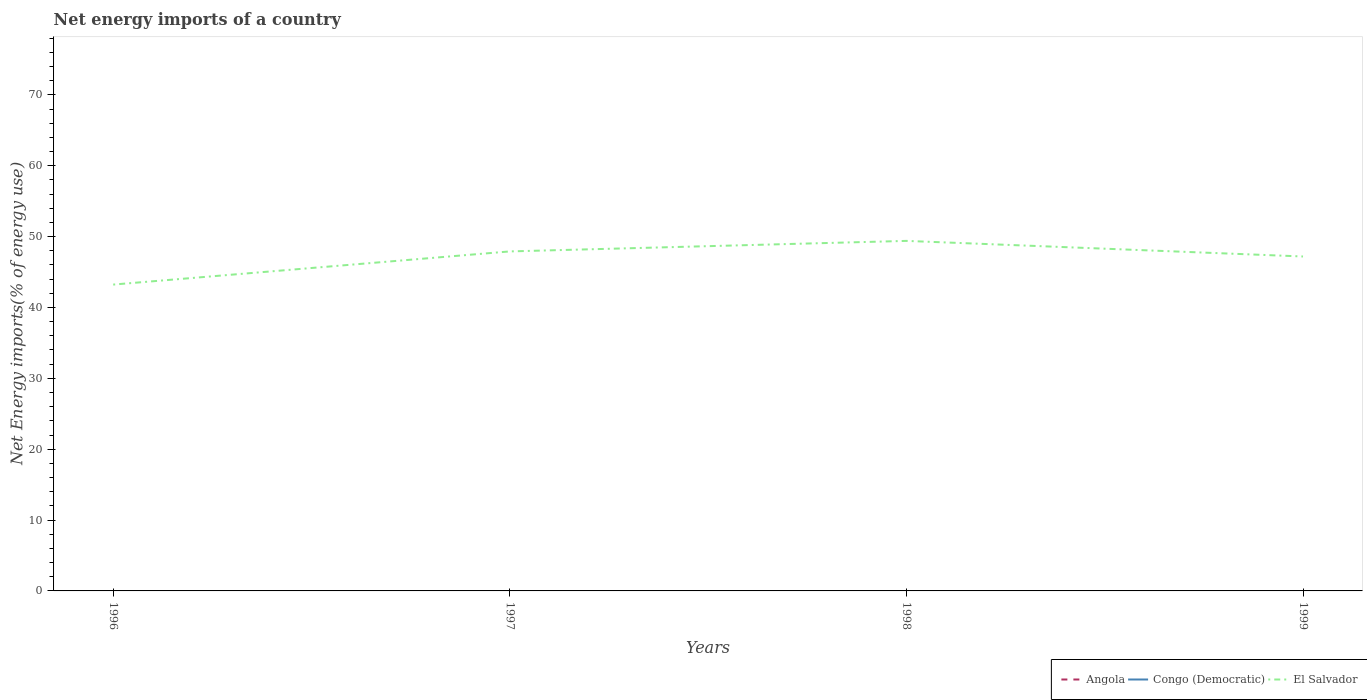How many different coloured lines are there?
Your answer should be compact. 1. Does the line corresponding to Congo (Democratic) intersect with the line corresponding to Angola?
Provide a succinct answer. No. Across all years, what is the maximum net energy imports in El Salvador?
Ensure brevity in your answer.  43.23. What is the total net energy imports in El Salvador in the graph?
Your answer should be very brief. 0.72. What is the difference between the highest and the second highest net energy imports in El Salvador?
Give a very brief answer. 6.16. How many lines are there?
Your response must be concise. 1. How many years are there in the graph?
Offer a terse response. 4. What is the difference between two consecutive major ticks on the Y-axis?
Your answer should be very brief. 10. Are the values on the major ticks of Y-axis written in scientific E-notation?
Your answer should be very brief. No. Does the graph contain grids?
Make the answer very short. No. Where does the legend appear in the graph?
Your answer should be compact. Bottom right. How many legend labels are there?
Make the answer very short. 3. What is the title of the graph?
Give a very brief answer. Net energy imports of a country. Does "Ghana" appear as one of the legend labels in the graph?
Give a very brief answer. No. What is the label or title of the Y-axis?
Give a very brief answer. Net Energy imports(% of energy use). What is the Net Energy imports(% of energy use) of Angola in 1996?
Keep it short and to the point. 0. What is the Net Energy imports(% of energy use) of Congo (Democratic) in 1996?
Provide a short and direct response. 0. What is the Net Energy imports(% of energy use) of El Salvador in 1996?
Your response must be concise. 43.23. What is the Net Energy imports(% of energy use) in Angola in 1997?
Keep it short and to the point. 0. What is the Net Energy imports(% of energy use) in El Salvador in 1997?
Your answer should be compact. 47.91. What is the Net Energy imports(% of energy use) of Angola in 1998?
Keep it short and to the point. 0. What is the Net Energy imports(% of energy use) of Congo (Democratic) in 1998?
Your answer should be very brief. 0. What is the Net Energy imports(% of energy use) in El Salvador in 1998?
Your response must be concise. 49.39. What is the Net Energy imports(% of energy use) in Congo (Democratic) in 1999?
Give a very brief answer. 0. What is the Net Energy imports(% of energy use) of El Salvador in 1999?
Offer a very short reply. 47.19. Across all years, what is the maximum Net Energy imports(% of energy use) in El Salvador?
Offer a very short reply. 49.39. Across all years, what is the minimum Net Energy imports(% of energy use) of El Salvador?
Make the answer very short. 43.23. What is the total Net Energy imports(% of energy use) in El Salvador in the graph?
Ensure brevity in your answer.  187.72. What is the difference between the Net Energy imports(% of energy use) of El Salvador in 1996 and that in 1997?
Make the answer very short. -4.68. What is the difference between the Net Energy imports(% of energy use) of El Salvador in 1996 and that in 1998?
Offer a terse response. -6.16. What is the difference between the Net Energy imports(% of energy use) of El Salvador in 1996 and that in 1999?
Make the answer very short. -3.96. What is the difference between the Net Energy imports(% of energy use) in El Salvador in 1997 and that in 1998?
Your answer should be compact. -1.48. What is the difference between the Net Energy imports(% of energy use) of El Salvador in 1997 and that in 1999?
Offer a terse response. 0.72. What is the difference between the Net Energy imports(% of energy use) of El Salvador in 1998 and that in 1999?
Offer a very short reply. 2.2. What is the average Net Energy imports(% of energy use) of Congo (Democratic) per year?
Make the answer very short. 0. What is the average Net Energy imports(% of energy use) of El Salvador per year?
Provide a succinct answer. 46.93. What is the ratio of the Net Energy imports(% of energy use) in El Salvador in 1996 to that in 1997?
Provide a succinct answer. 0.9. What is the ratio of the Net Energy imports(% of energy use) of El Salvador in 1996 to that in 1998?
Your answer should be very brief. 0.88. What is the ratio of the Net Energy imports(% of energy use) of El Salvador in 1996 to that in 1999?
Offer a very short reply. 0.92. What is the ratio of the Net Energy imports(% of energy use) of El Salvador in 1997 to that in 1998?
Provide a succinct answer. 0.97. What is the ratio of the Net Energy imports(% of energy use) in El Salvador in 1997 to that in 1999?
Ensure brevity in your answer.  1.02. What is the ratio of the Net Energy imports(% of energy use) of El Salvador in 1998 to that in 1999?
Keep it short and to the point. 1.05. What is the difference between the highest and the second highest Net Energy imports(% of energy use) in El Salvador?
Offer a very short reply. 1.48. What is the difference between the highest and the lowest Net Energy imports(% of energy use) in El Salvador?
Provide a succinct answer. 6.16. 